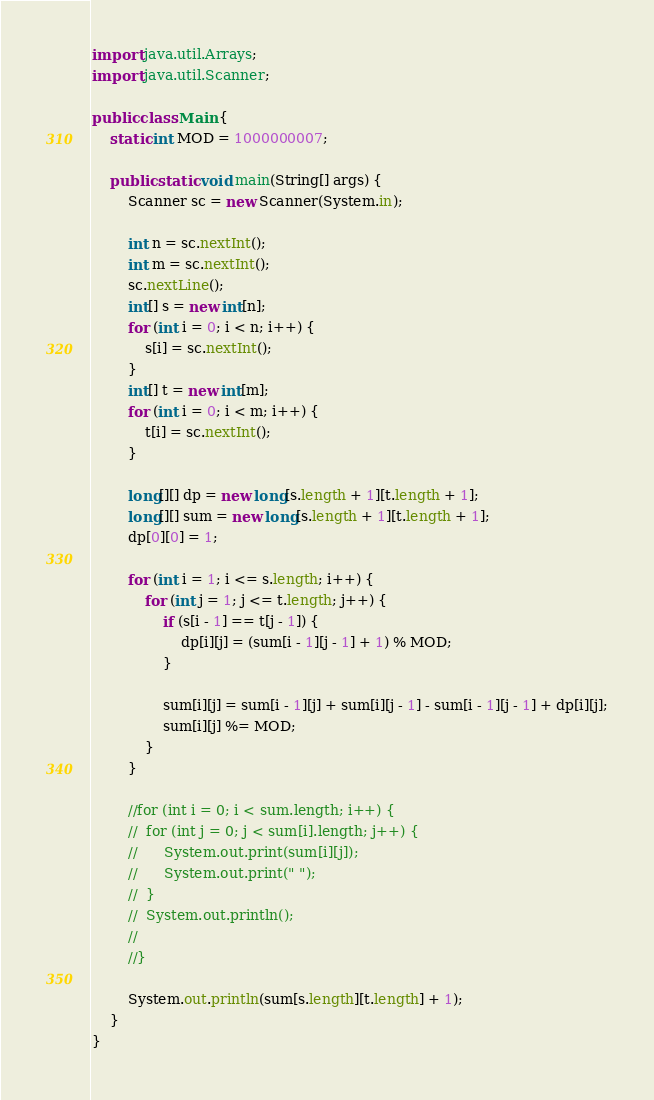Convert code to text. <code><loc_0><loc_0><loc_500><loc_500><_Java_>import java.util.Arrays;
import java.util.Scanner;

public class Main {
	static int MOD = 1000000007;

	public static void main(String[] args) {
		Scanner sc = new Scanner(System.in);

		int n = sc.nextInt();
		int m = sc.nextInt();
		sc.nextLine();
		int[] s = new int[n];
		for (int i = 0; i < n; i++) {
			s[i] = sc.nextInt();
		}
		int[] t = new int[m];
		for (int i = 0; i < m; i++) {
			t[i] = sc.nextInt();
		}

		long[][] dp = new long[s.length + 1][t.length + 1];
		long[][] sum = new long[s.length + 1][t.length + 1];
		dp[0][0] = 1;

		for (int i = 1; i <= s.length; i++) {
			for (int j = 1; j <= t.length; j++) {
				if (s[i - 1] == t[j - 1]) {
					dp[i][j] = (sum[i - 1][j - 1] + 1) % MOD;
				}

				sum[i][j] = sum[i - 1][j] + sum[i][j - 1] - sum[i - 1][j - 1] + dp[i][j];
				sum[i][j] %= MOD;
			}
		}

		//for (int i = 0; i < sum.length; i++) {
		//	for (int j = 0; j < sum[i].length; j++) {
		//		System.out.print(sum[i][j]);
		//		System.out.print(" ");
		//	}
		//	System.out.println();
		//
		//}

		System.out.println(sum[s.length][t.length] + 1);
	}
}
</code> 